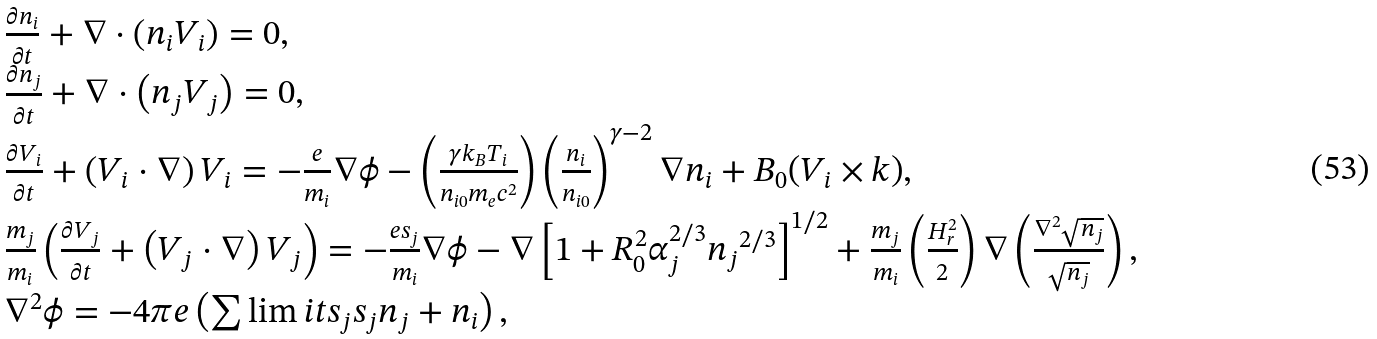<formula> <loc_0><loc_0><loc_500><loc_500>\begin{array} { l } \frac { { \partial { n _ { i } } } } { \partial t } + \nabla \cdot \left ( { { n _ { i } } { { V } _ { i } } } \right ) = 0 , \\ \frac { { \partial { n _ { j } } } } { \partial t } + \nabla \cdot \left ( { { n _ { j } } { { V } _ { j } } } \right ) = 0 , \\ \frac { { \partial { { V } _ { i } } } } { \partial t } + \left ( { { { V } _ { i } } \cdot \nabla } \right ) { { V } _ { i } } = - \frac { e } { m _ { i } } \nabla \phi - \left ( { \frac { { \gamma { k _ { B } } { T _ { i } } } } { { n _ { i 0 } { m _ { e } } { c ^ { 2 } } } } } \right ) \left ( \frac { n _ { i } } { n _ { i 0 } } \right ) ^ { \gamma - 2 } \nabla { n _ { i } } + B _ { 0 } ( { { V } _ { i } } \times { k } ) , \\ \frac { m _ { j } } { m _ { i } } \left ( { \frac { { \partial { { V } _ { j } } } } { \partial t } + \left ( { { { V } _ { j } } \cdot \nabla } \right ) { { V } _ { j } } } \right ) = - \frac { e s _ { j } } { m _ { i } } \nabla \phi - \nabla \left [ { 1 + { R _ { 0 } ^ { 2 } \alpha _ { j } ^ { 2 / 3 } { n _ { j } } ^ { 2 / 3 } } } \right ] ^ { 1 / 2 } + { \frac { m _ { j } } { m _ { i } } } \left ( \frac { { { H _ { r } ^ { 2 } } } } { 2 } \right ) \nabla \left ( { \frac { { { \nabla ^ { 2 } } \sqrt { n _ { j } } } } { { \sqrt { n _ { j } } } } } \right ) , \\ { \nabla ^ { 2 } } \phi = - 4 \pi e \left ( { \sum \lim i t s _ { j } { { s _ { j } } { n _ { j } } } + { n _ { i } } } \right ) , \\ \end{array}</formula> 